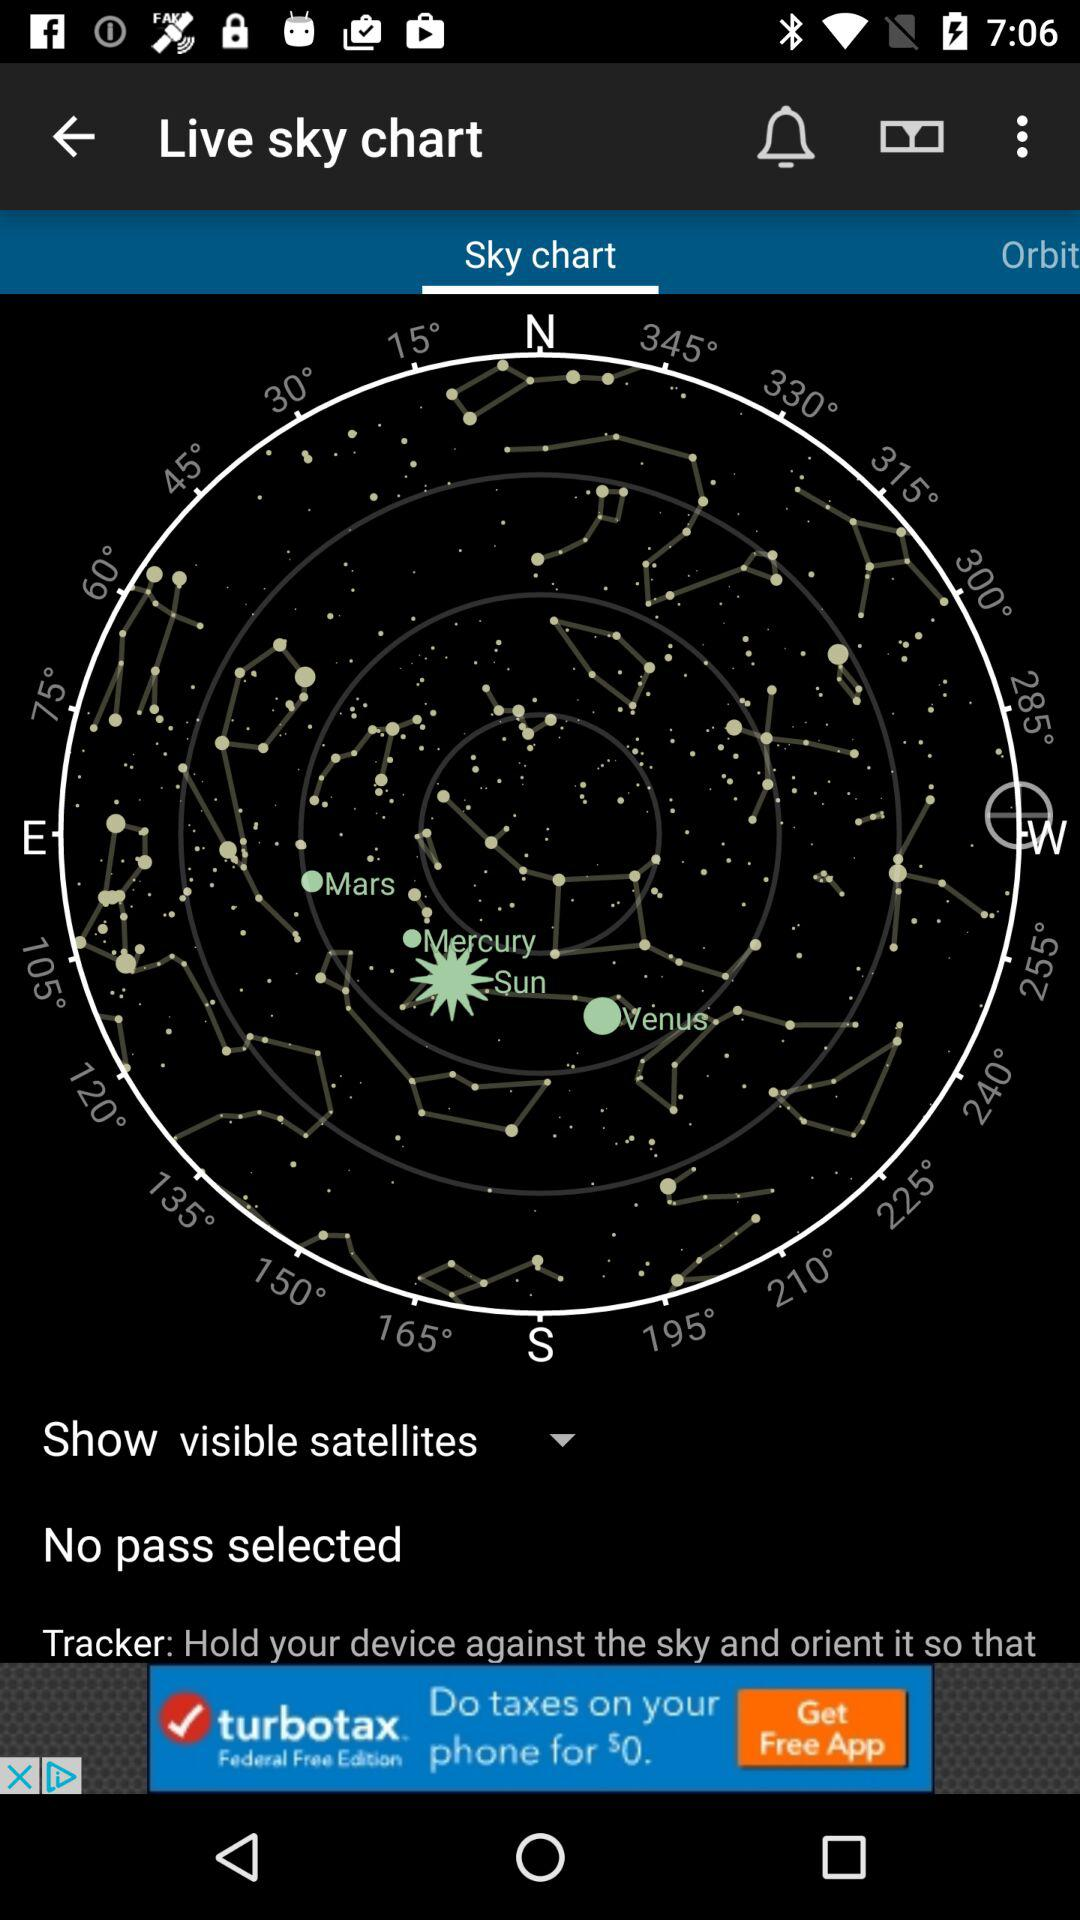Which planets are shown in the chart? The shown planets are Mars, Mercury and Venus. 